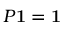Convert formula to latex. <formula><loc_0><loc_0><loc_500><loc_500>P 1 = 1</formula> 